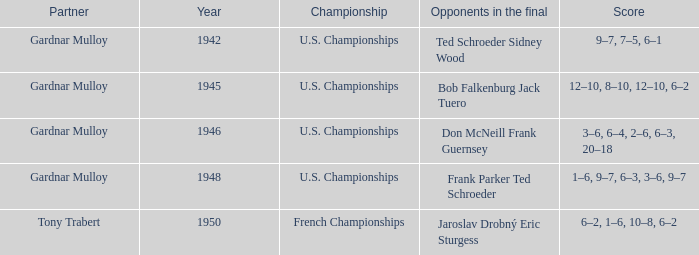What is the most recent year gardnar mulloy played as a partner and score was 12–10, 8–10, 12–10, 6–2? 1945.0. Would you be able to parse every entry in this table? {'header': ['Partner', 'Year', 'Championship', 'Opponents in the final', 'Score'], 'rows': [['Gardnar Mulloy', '1942', 'U.S. Championships', 'Ted Schroeder Sidney Wood', '9–7, 7–5, 6–1'], ['Gardnar Mulloy', '1945', 'U.S. Championships', 'Bob Falkenburg Jack Tuero', '12–10, 8–10, 12–10, 6–2'], ['Gardnar Mulloy', '1946', 'U.S. Championships', 'Don McNeill Frank Guernsey', '3–6, 6–4, 2–6, 6–3, 20–18'], ['Gardnar Mulloy', '1948', 'U.S. Championships', 'Frank Parker Ted Schroeder', '1–6, 9–7, 6–3, 3–6, 9–7'], ['Tony Trabert', '1950', 'French Championships', 'Jaroslav Drobný Eric Sturgess', '6–2, 1–6, 10–8, 6–2']]} 